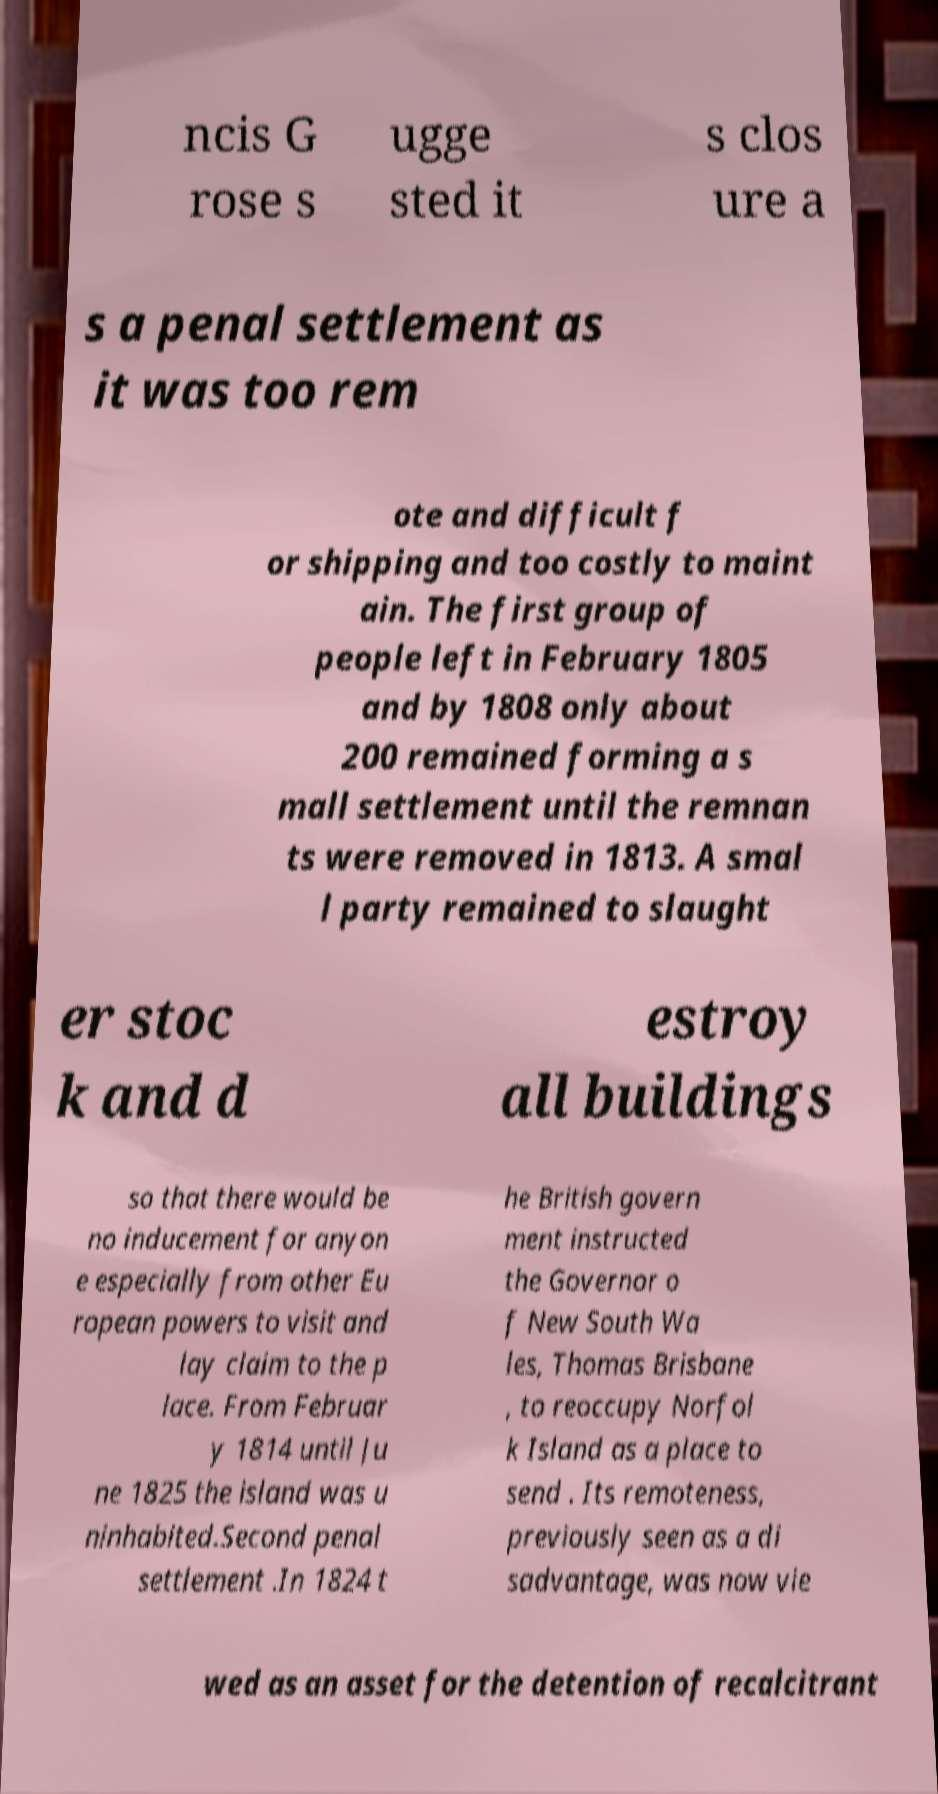Please identify and transcribe the text found in this image. ncis G rose s ugge sted it s clos ure a s a penal settlement as it was too rem ote and difficult f or shipping and too costly to maint ain. The first group of people left in February 1805 and by 1808 only about 200 remained forming a s mall settlement until the remnan ts were removed in 1813. A smal l party remained to slaught er stoc k and d estroy all buildings so that there would be no inducement for anyon e especially from other Eu ropean powers to visit and lay claim to the p lace. From Februar y 1814 until Ju ne 1825 the island was u ninhabited.Second penal settlement .In 1824 t he British govern ment instructed the Governor o f New South Wa les, Thomas Brisbane , to reoccupy Norfol k Island as a place to send . Its remoteness, previously seen as a di sadvantage, was now vie wed as an asset for the detention of recalcitrant 